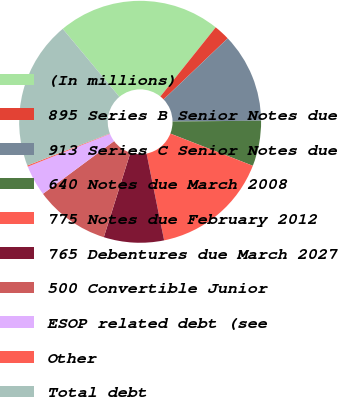Convert chart. <chart><loc_0><loc_0><loc_500><loc_500><pie_chart><fcel>(In millions)<fcel>895 Series B Senior Notes due<fcel>913 Series C Senior Notes due<fcel>640 Notes due March 2008<fcel>775 Notes due February 2012<fcel>765 Debentures due March 2027<fcel>500 Convertible Junior<fcel>ESOP related debt (see<fcel>Other<fcel>Total debt<nl><fcel>21.79%<fcel>2.14%<fcel>11.97%<fcel>6.07%<fcel>15.9%<fcel>8.03%<fcel>10.0%<fcel>4.1%<fcel>0.17%<fcel>19.83%<nl></chart> 